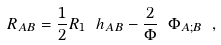<formula> <loc_0><loc_0><loc_500><loc_500>R _ { A B } = \frac { 1 } { 2 } R _ { 1 } \ h _ { A B } - \frac { 2 } { \Phi } \ \Phi _ { A ; B } \ ,</formula> 